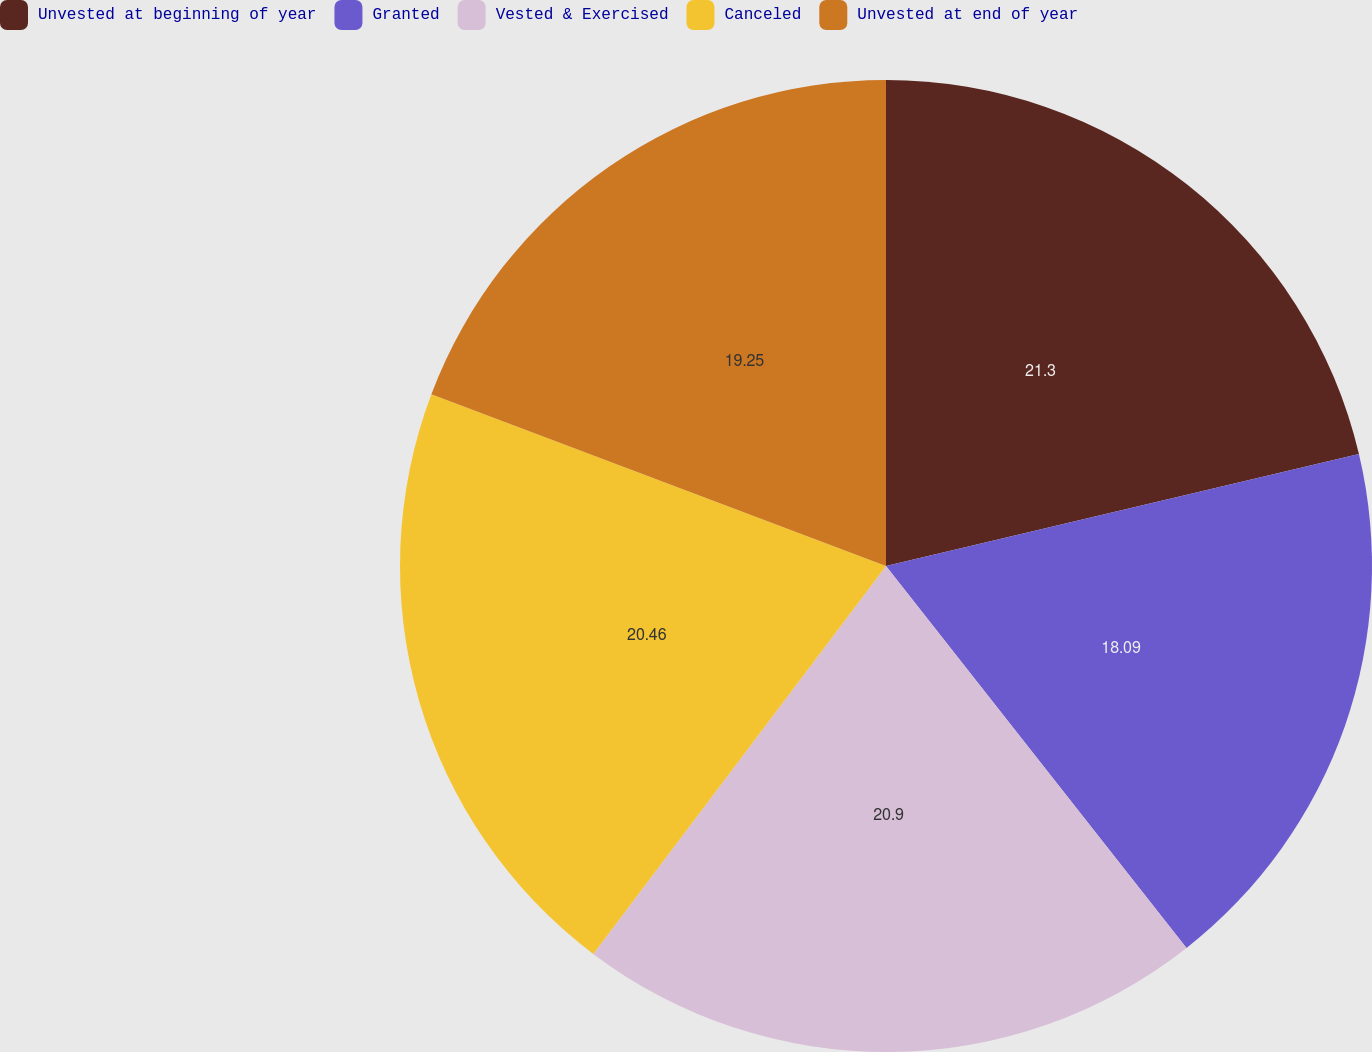<chart> <loc_0><loc_0><loc_500><loc_500><pie_chart><fcel>Unvested at beginning of year<fcel>Granted<fcel>Vested & Exercised<fcel>Canceled<fcel>Unvested at end of year<nl><fcel>21.3%<fcel>18.09%<fcel>20.9%<fcel>20.46%<fcel>19.25%<nl></chart> 